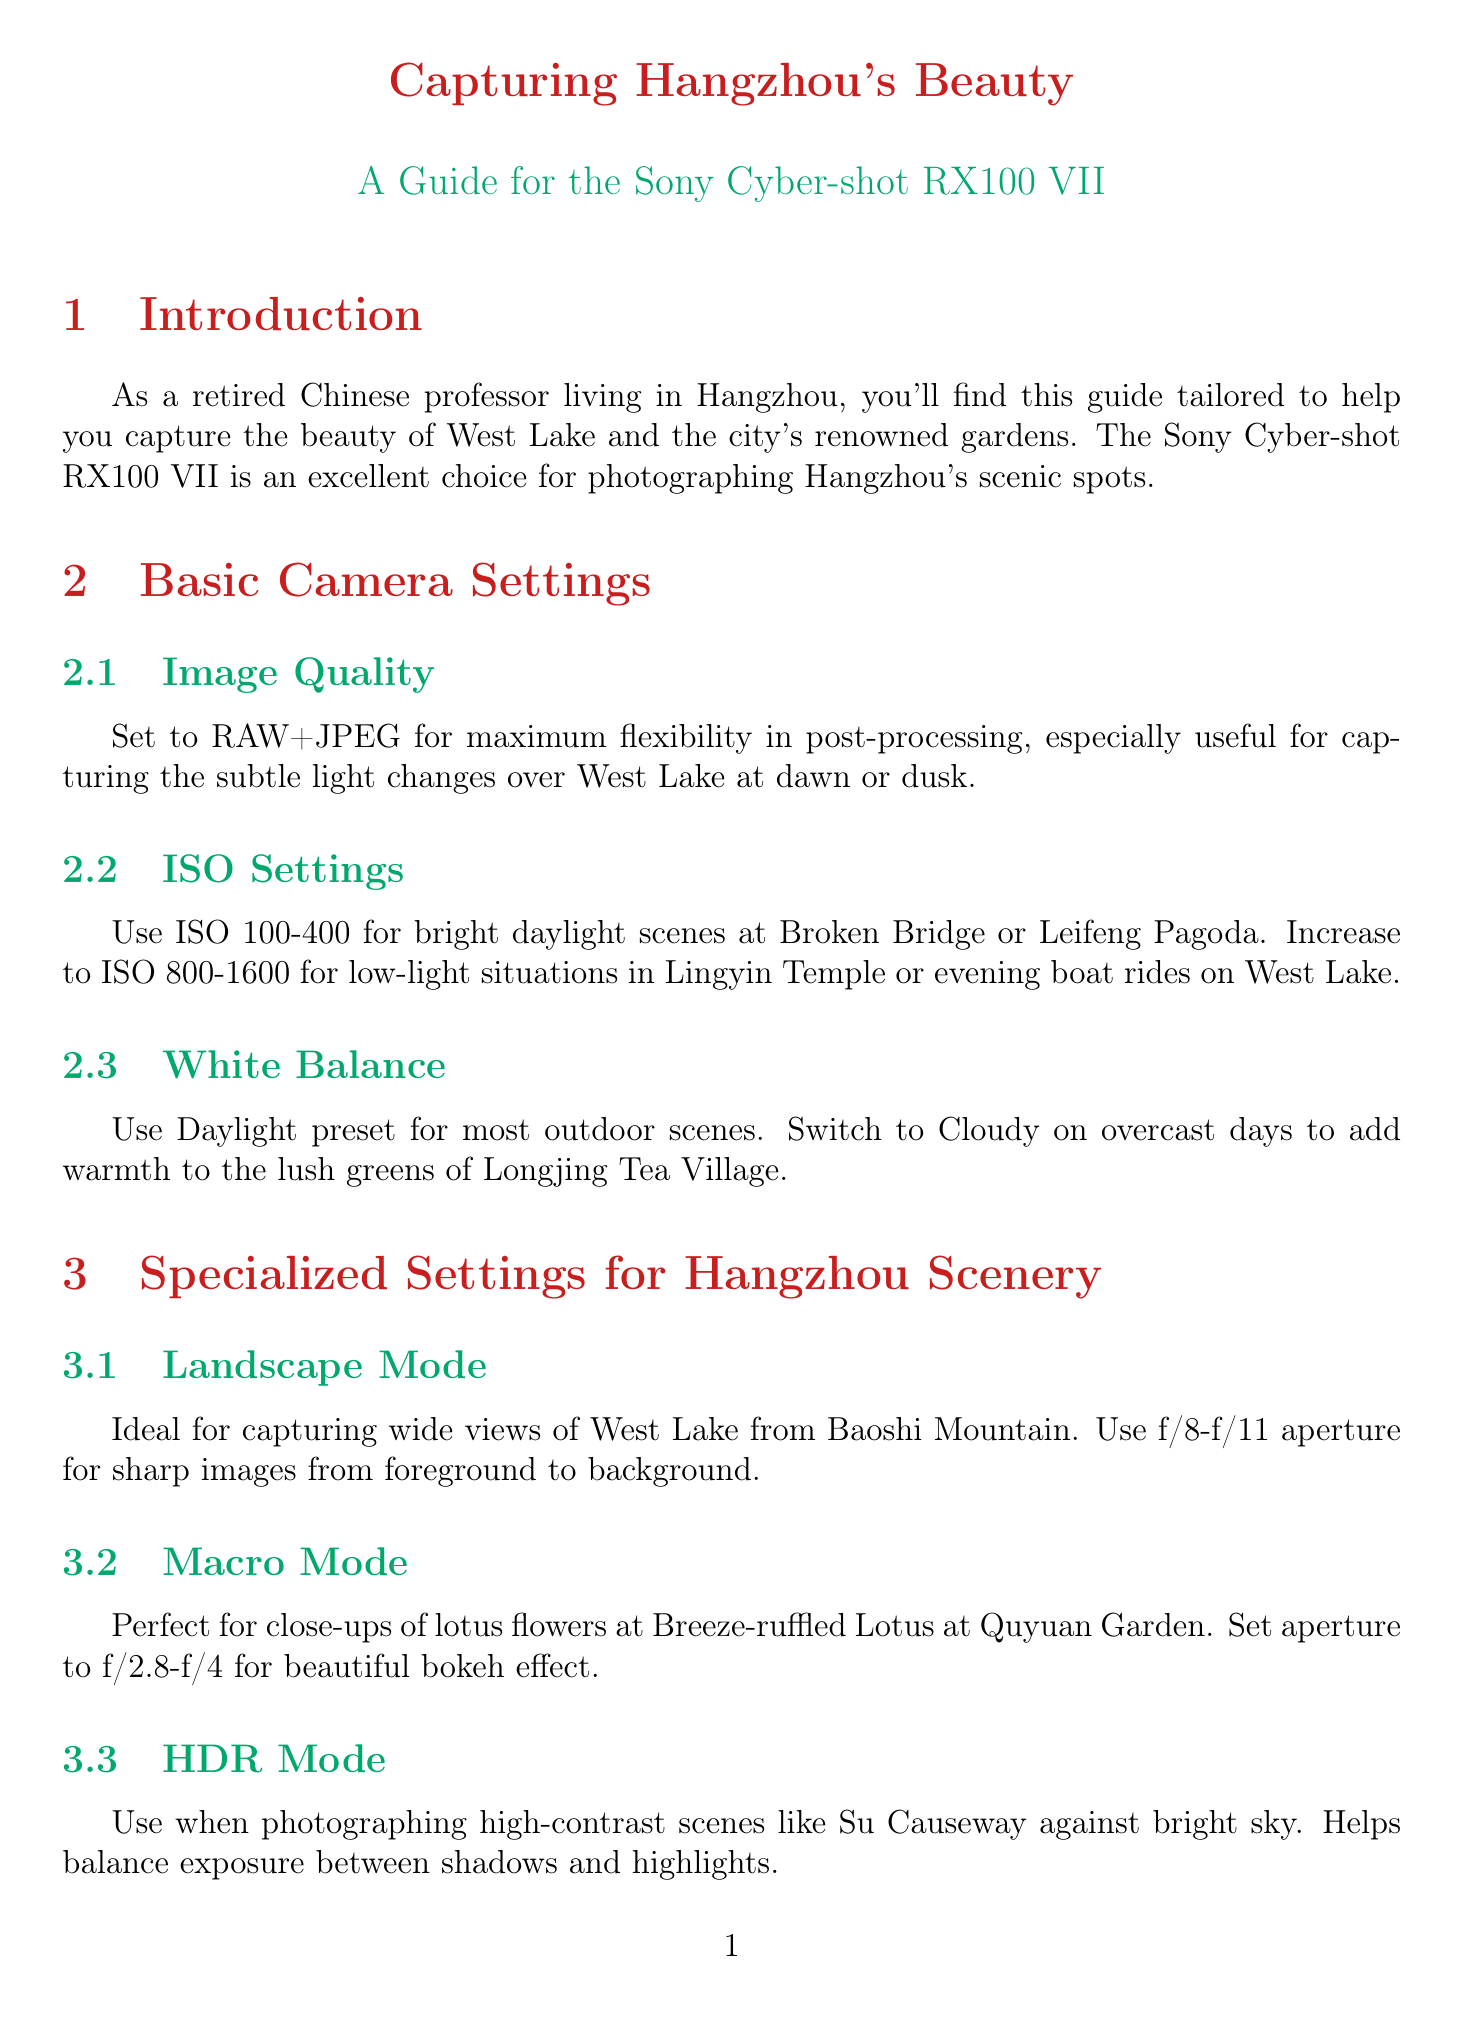What is the camera model featured in the guide? The camera model mentioned in the document is the Sony Cyber-shot RX100 VII.
Answer: Sony Cyber-shot RX100 VII What ISO setting is recommended for low-light situations? The document suggests using ISO 800-1600 for low-light situations.
Answer: ISO 800-1600 In which mode is an aperture of f/2.8-f/4 recommended? The document states that f/2.8-f/4 aperture is recommended for Macro Mode.
Answer: Macro Mode What is the suggested white balance for overcast days? According to the guide, the suggested white balance for overcast days is Cloudy.
Answer: Cloudy Which composition technique applies to framing Three Pools Mirroring the Moon? The document indicates that the Rule of Thirds applies to framing this location.
Answer: Rule of Thirds What color profile should be used in Spring for cherry blossoms? The guide recommends using the Vivid color profile in Spring to enhance cherry blossoms.
Answer: Vivid color profile When is Night Scene Mode useful? Night Scene Mode is useful for capturing illuminated scenes, such as the Musical Fountain show.
Answer: Illuminated scenes What seasonal adjustment is suggested for snow scenes? The document suggests increasing exposure compensation by +0.7 to +1.0 for snow scenes.
Answer: +0.7 to +1.0 What specialized setting is ideal for sweeping views? The ideal specialized setting for sweeping views is Panorama Mode.
Answer: Panorama Mode 